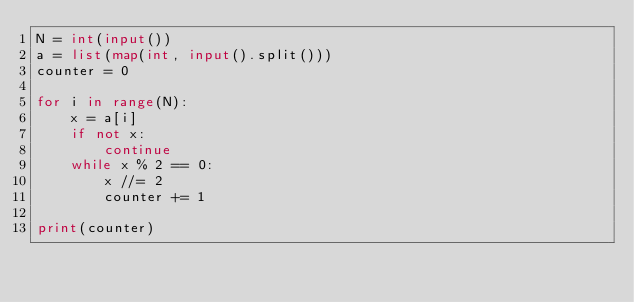Convert code to text. <code><loc_0><loc_0><loc_500><loc_500><_Python_>N = int(input())
a = list(map(int, input().split()))
counter = 0

for i in range(N):
    x = a[i]
    if not x:
        continue
    while x % 2 == 0:
        x //= 2
        counter += 1

print(counter)
</code> 